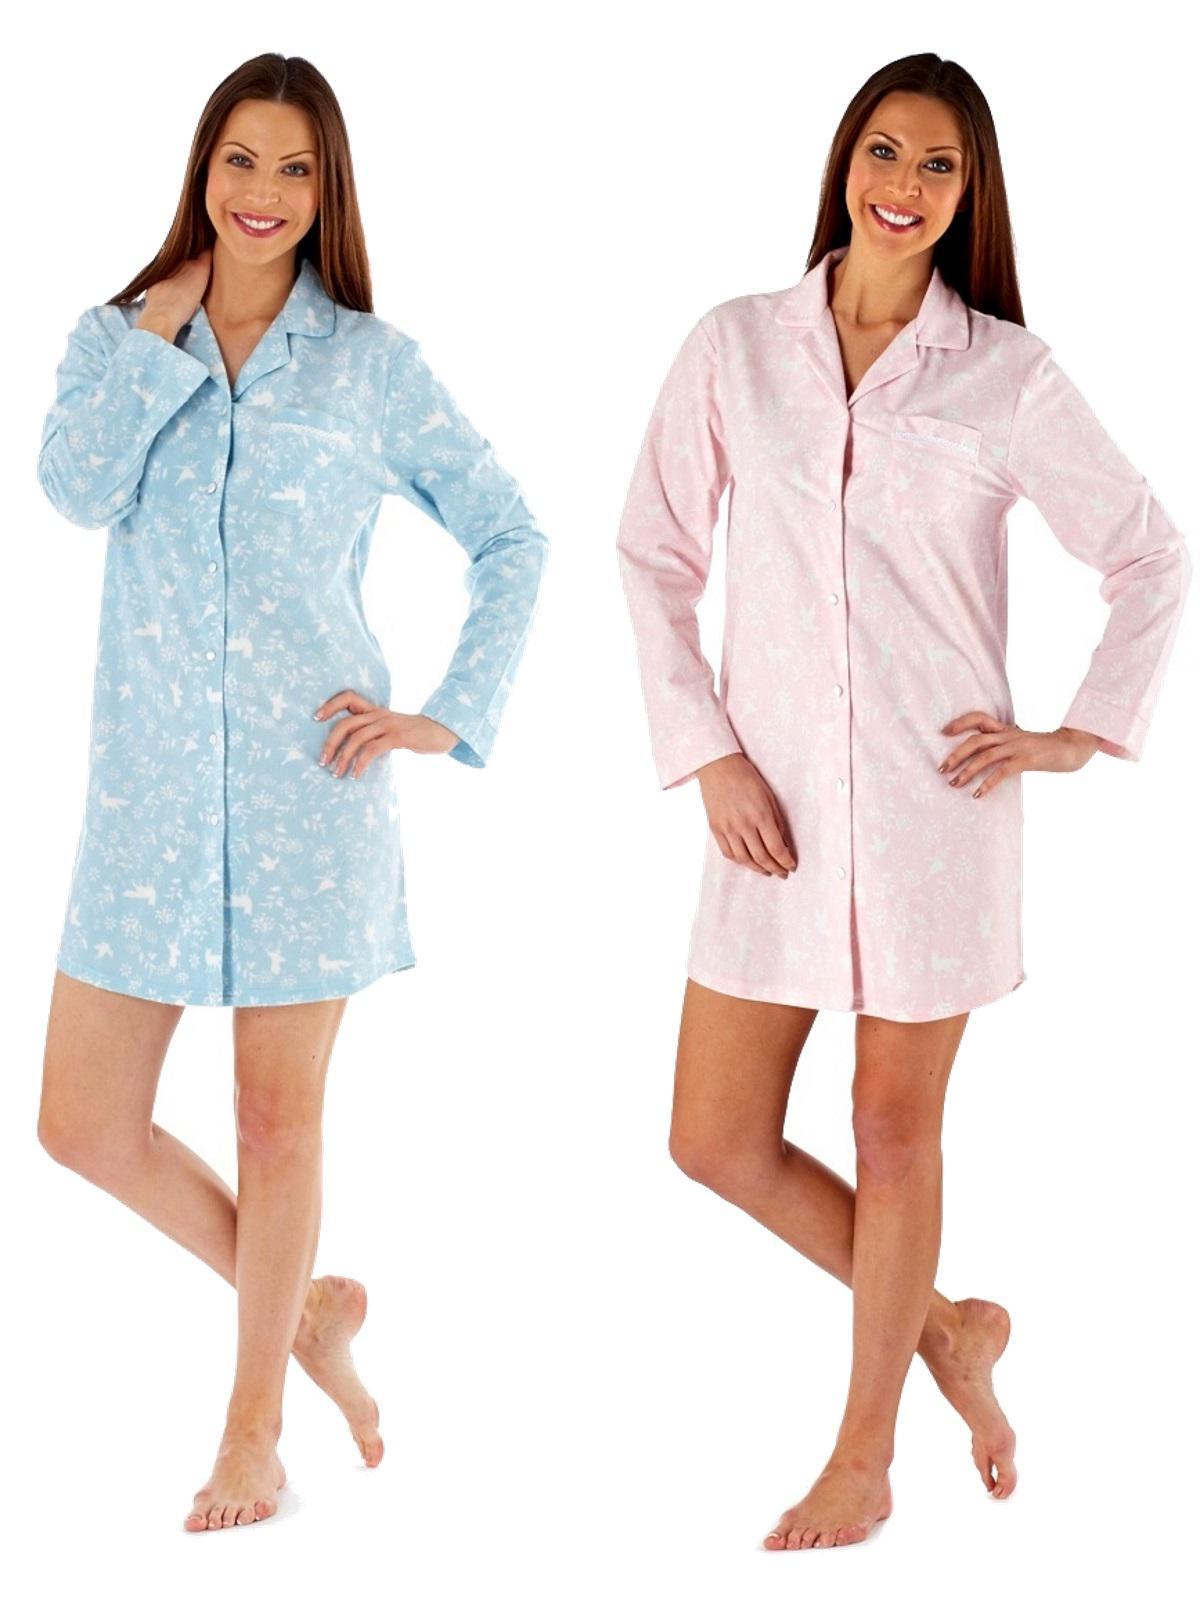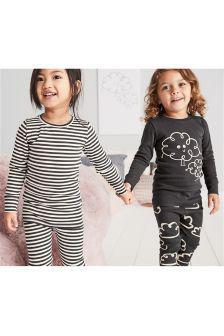The first image is the image on the left, the second image is the image on the right. Evaluate the accuracy of this statement regarding the images: "Women are wearing shirts with cartoon animals sleeping on them in one of the images.". Is it true? Answer yes or no. No. The first image is the image on the left, the second image is the image on the right. Considering the images on both sides, is "More than one pajama set has a depiction of an animal on the top." valid? Answer yes or no. No. 